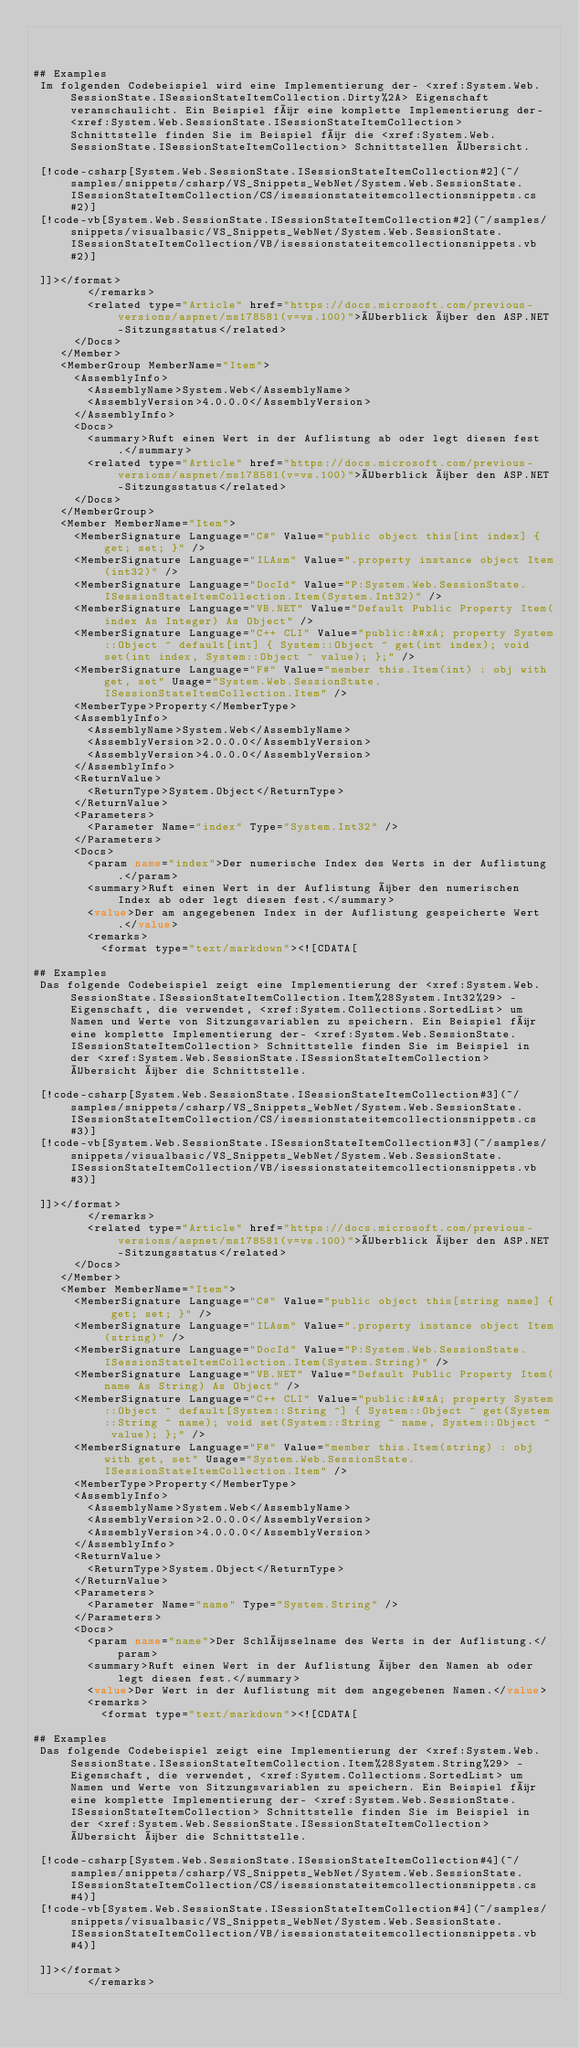<code> <loc_0><loc_0><loc_500><loc_500><_XML_>


## Examples
 Im folgenden Codebeispiel wird eine Implementierung der- <xref:System.Web.SessionState.ISessionStateItemCollection.Dirty%2A> Eigenschaft veranschaulicht. Ein Beispiel für eine komplette Implementierung der- <xref:System.Web.SessionState.ISessionStateItemCollection> Schnittstelle finden Sie im Beispiel für die <xref:System.Web.SessionState.ISessionStateItemCollection> Schnittstellen Übersicht.

 [!code-csharp[System.Web.SessionState.ISessionStateItemCollection#2](~/samples/snippets/csharp/VS_Snippets_WebNet/System.Web.SessionState.ISessionStateItemCollection/CS/isessionstateitemcollectionsnippets.cs#2)]
 [!code-vb[System.Web.SessionState.ISessionStateItemCollection#2](~/samples/snippets/visualbasic/VS_Snippets_WebNet/System.Web.SessionState.ISessionStateItemCollection/VB/isessionstateitemcollectionsnippets.vb#2)]

 ]]></format>
        </remarks>
        <related type="Article" href="https://docs.microsoft.com/previous-versions/aspnet/ms178581(v=vs.100)">Überblick über den ASP.NET-Sitzungsstatus</related>
      </Docs>
    </Member>
    <MemberGroup MemberName="Item">
      <AssemblyInfo>
        <AssemblyName>System.Web</AssemblyName>
        <AssemblyVersion>4.0.0.0</AssemblyVersion>
      </AssemblyInfo>
      <Docs>
        <summary>Ruft einen Wert in der Auflistung ab oder legt diesen fest.</summary>
        <related type="Article" href="https://docs.microsoft.com/previous-versions/aspnet/ms178581(v=vs.100)">Überblick über den ASP.NET-Sitzungsstatus</related>
      </Docs>
    </MemberGroup>
    <Member MemberName="Item">
      <MemberSignature Language="C#" Value="public object this[int index] { get; set; }" />
      <MemberSignature Language="ILAsm" Value=".property instance object Item(int32)" />
      <MemberSignature Language="DocId" Value="P:System.Web.SessionState.ISessionStateItemCollection.Item(System.Int32)" />
      <MemberSignature Language="VB.NET" Value="Default Public Property Item(index As Integer) As Object" />
      <MemberSignature Language="C++ CLI" Value="public:&#xA; property System::Object ^ default[int] { System::Object ^ get(int index); void set(int index, System::Object ^ value); };" />
      <MemberSignature Language="F#" Value="member this.Item(int) : obj with get, set" Usage="System.Web.SessionState.ISessionStateItemCollection.Item" />
      <MemberType>Property</MemberType>
      <AssemblyInfo>
        <AssemblyName>System.Web</AssemblyName>
        <AssemblyVersion>2.0.0.0</AssemblyVersion>
        <AssemblyVersion>4.0.0.0</AssemblyVersion>
      </AssemblyInfo>
      <ReturnValue>
        <ReturnType>System.Object</ReturnType>
      </ReturnValue>
      <Parameters>
        <Parameter Name="index" Type="System.Int32" />
      </Parameters>
      <Docs>
        <param name="index">Der numerische Index des Werts in der Auflistung.</param>
        <summary>Ruft einen Wert in der Auflistung über den numerischen Index ab oder legt diesen fest.</summary>
        <value>Der am angegebenen Index in der Auflistung gespeicherte Wert.</value>
        <remarks>
          <format type="text/markdown"><![CDATA[

## Examples
 Das folgende Codebeispiel zeigt eine Implementierung der <xref:System.Web.SessionState.ISessionStateItemCollection.Item%28System.Int32%29> -Eigenschaft, die verwendet, <xref:System.Collections.SortedList> um Namen und Werte von Sitzungsvariablen zu speichern. Ein Beispiel für eine komplette Implementierung der- <xref:System.Web.SessionState.ISessionStateItemCollection> Schnittstelle finden Sie im Beispiel in der <xref:System.Web.SessionState.ISessionStateItemCollection> Übersicht über die Schnittstelle.

 [!code-csharp[System.Web.SessionState.ISessionStateItemCollection#3](~/samples/snippets/csharp/VS_Snippets_WebNet/System.Web.SessionState.ISessionStateItemCollection/CS/isessionstateitemcollectionsnippets.cs#3)]
 [!code-vb[System.Web.SessionState.ISessionStateItemCollection#3](~/samples/snippets/visualbasic/VS_Snippets_WebNet/System.Web.SessionState.ISessionStateItemCollection/VB/isessionstateitemcollectionsnippets.vb#3)]

 ]]></format>
        </remarks>
        <related type="Article" href="https://docs.microsoft.com/previous-versions/aspnet/ms178581(v=vs.100)">Überblick über den ASP.NET-Sitzungsstatus</related>
      </Docs>
    </Member>
    <Member MemberName="Item">
      <MemberSignature Language="C#" Value="public object this[string name] { get; set; }" />
      <MemberSignature Language="ILAsm" Value=".property instance object Item(string)" />
      <MemberSignature Language="DocId" Value="P:System.Web.SessionState.ISessionStateItemCollection.Item(System.String)" />
      <MemberSignature Language="VB.NET" Value="Default Public Property Item(name As String) As Object" />
      <MemberSignature Language="C++ CLI" Value="public:&#xA; property System::Object ^ default[System::String ^] { System::Object ^ get(System::String ^ name); void set(System::String ^ name, System::Object ^ value); };" />
      <MemberSignature Language="F#" Value="member this.Item(string) : obj with get, set" Usage="System.Web.SessionState.ISessionStateItemCollection.Item" />
      <MemberType>Property</MemberType>
      <AssemblyInfo>
        <AssemblyName>System.Web</AssemblyName>
        <AssemblyVersion>2.0.0.0</AssemblyVersion>
        <AssemblyVersion>4.0.0.0</AssemblyVersion>
      </AssemblyInfo>
      <ReturnValue>
        <ReturnType>System.Object</ReturnType>
      </ReturnValue>
      <Parameters>
        <Parameter Name="name" Type="System.String" />
      </Parameters>
      <Docs>
        <param name="name">Der Schlüsselname des Werts in der Auflistung.</param>
        <summary>Ruft einen Wert in der Auflistung über den Namen ab oder legt diesen fest.</summary>
        <value>Der Wert in der Auflistung mit dem angegebenen Namen.</value>
        <remarks>
          <format type="text/markdown"><![CDATA[

## Examples
 Das folgende Codebeispiel zeigt eine Implementierung der <xref:System.Web.SessionState.ISessionStateItemCollection.Item%28System.String%29> -Eigenschaft, die verwendet, <xref:System.Collections.SortedList> um Namen und Werte von Sitzungsvariablen zu speichern. Ein Beispiel für eine komplette Implementierung der- <xref:System.Web.SessionState.ISessionStateItemCollection> Schnittstelle finden Sie im Beispiel in der <xref:System.Web.SessionState.ISessionStateItemCollection> Übersicht über die Schnittstelle.

 [!code-csharp[System.Web.SessionState.ISessionStateItemCollection#4](~/samples/snippets/csharp/VS_Snippets_WebNet/System.Web.SessionState.ISessionStateItemCollection/CS/isessionstateitemcollectionsnippets.cs#4)]
 [!code-vb[System.Web.SessionState.ISessionStateItemCollection#4](~/samples/snippets/visualbasic/VS_Snippets_WebNet/System.Web.SessionState.ISessionStateItemCollection/VB/isessionstateitemcollectionsnippets.vb#4)]

 ]]></format>
        </remarks></code> 